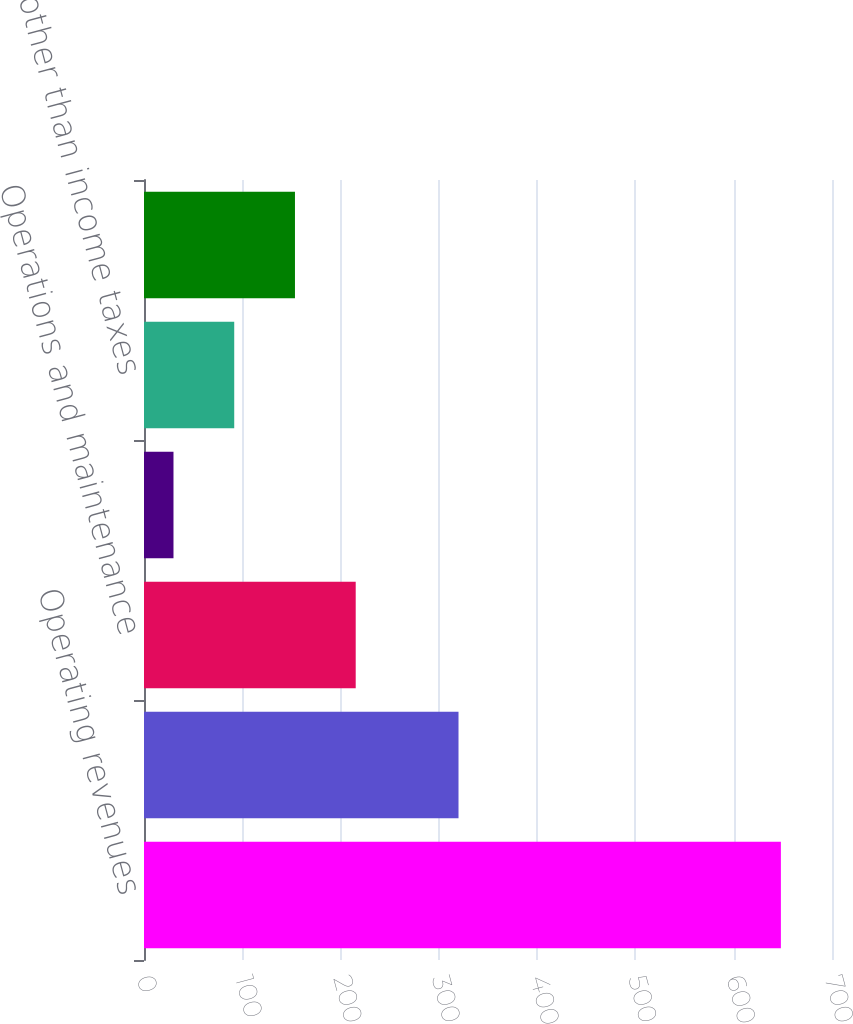Convert chart. <chart><loc_0><loc_0><loc_500><loc_500><bar_chart><fcel>Operating revenues<fcel>Net revenues<fcel>Operations and maintenance<fcel>Depreciation and amortization<fcel>Taxes other than income taxes<fcel>Operating income<nl><fcel>648<fcel>320<fcel>215.4<fcel>30<fcel>91.8<fcel>153.6<nl></chart> 